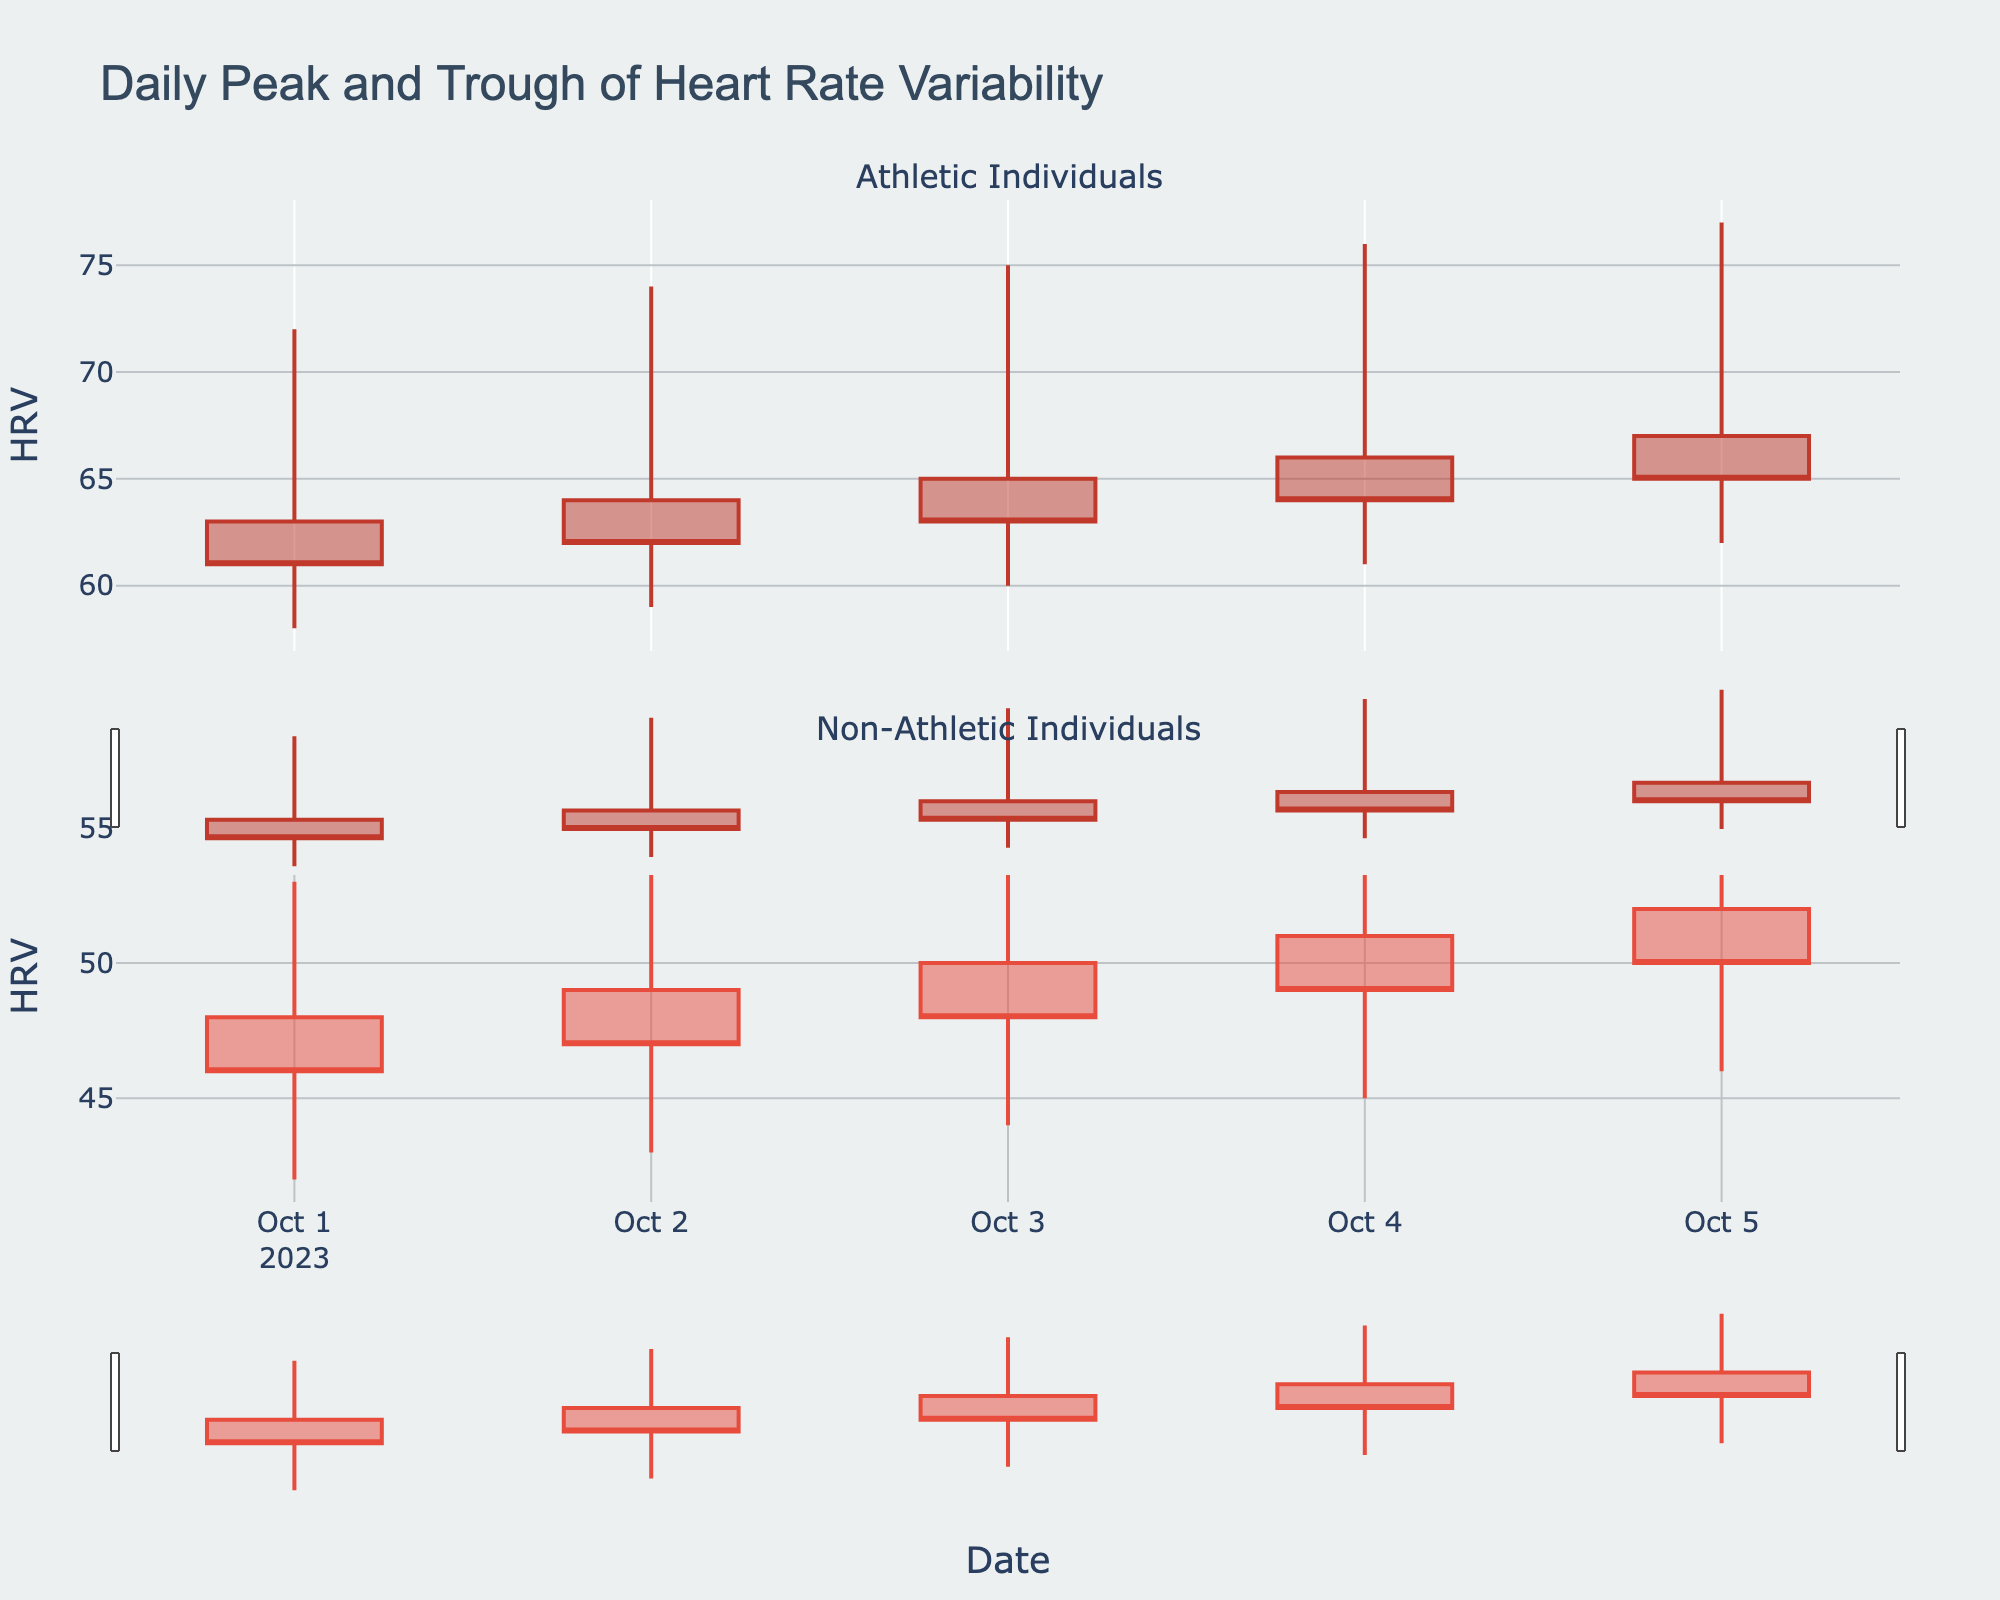How many days are represented in the plot? There are dates shown on the x-axis from October 1, 2023, to October 5, 2023, indicating a span of 5 days.
Answer: 5 What is the lowest HRV recorded for athletic individuals? The lowest HRV for athletic individuals is indicated by the lowest 'low' value in the plot, which is 58 on October 1, 2023.
Answer: 58 Which group has the highest HRV, and what is the value? Looking at the highest 'high' values for both groups, the athletic individuals have the highest HRV of 77 on October 5, 2023.
Answer: Athletic, 77 What is the average opening HRV for non-athletic individuals? The opening values for non-athletic individuals are 48, 49, 50, 51, and 52. Summing them up gives 250, and the average is 250/5.
Answer: 50 On which date did both groups show the maximum peak in HRV, and what were the values? The maximum HRV values for both groups are found by looking at the highest 'high' values for each group, which are 77 for athletic individuals on October 5, 2023, and 57 for non-athletic individuals on the same day.
Answer: October 5, 2023, 77 and 57 Compare the closing HRV values between athletic and non-athletic individuals on October 3, 2023. On October 3, the closing HRV for athletic individuals is 63 and for non-athletic individuals is 48.
Answer: 63 and 48 How does the trend in HRV from October 1 to October 5 differ between athletic and non-athletic individuals? The plot shows that athletic individuals have a consistently increasing trend in their HRV from a low of 58 to a peak of 77, while non-athletic individuals also show an increasing trend but with lower values, moving from 42 to 57.
Answer: Athletic: 58 to 77, Non-Athletic: 42 to 57 What is the difference in the lowest HRV values between October 2 and October 3 for non-athletic individuals? The lowest HRV for non-athletic individuals on October 2 is 43, and on October 3 it is 44. The difference is 44 - 43.
Answer: 1 Which group shows more variability in their HRV values? Comparing the range (high minus low) for each date, the athletic group shows a larger range of HRV values (e.g., 58 to 77) compared to the non-athletic group (e.g., 42 to 57), indicating more variability.
Answer: Athletic 